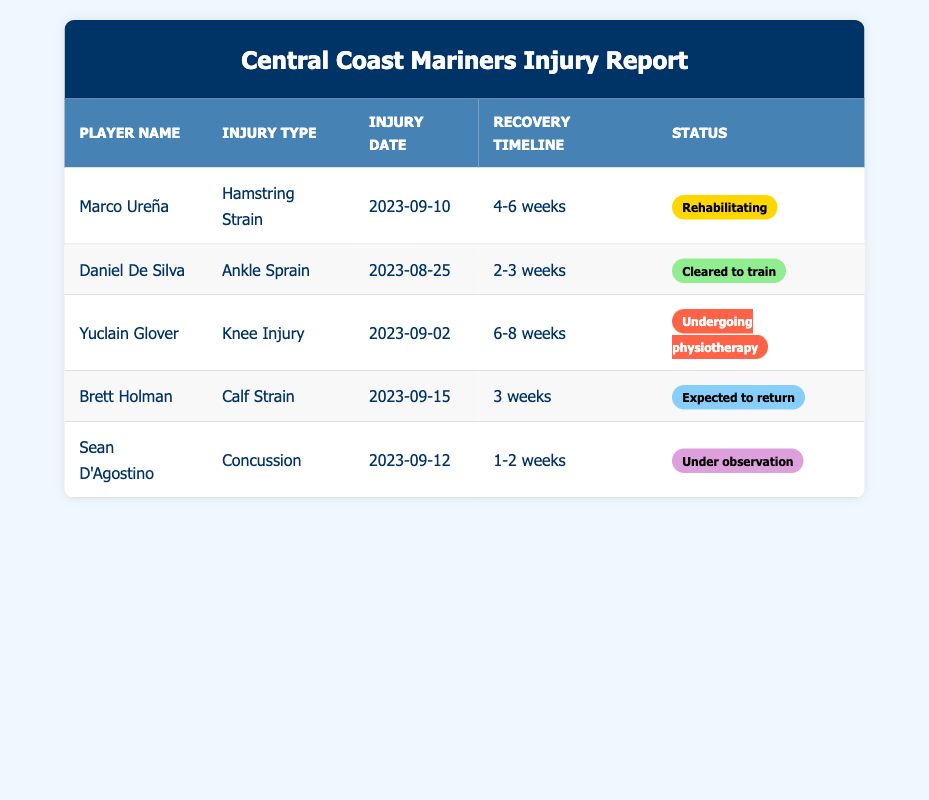What type of injury does Marco Ureña have? The table lists Marco Ureña's injury type as "Hamstring Strain." Since this information is shown directly in the "Injury Type" column for Marco Ureña, it's straightforward to retrieve.
Answer: Hamstring Strain When did Daniel De Silva sustain his injury? According to the table, Daniel De Silva's injury date is noted as "2023-08-25," which is found in the "Injury Date" column next to his name.
Answer: 2023-08-25 Which player has the longest expected recovery timeline? By comparing the recovery timelines in the table, Yuclain Glover has the longest estimated recovery period of "6-8 weeks." This is determined by looking at the "Recovery Timeline" column for each player and identifying the maximum duration.
Answer: Yuclain Glover Is Brett Holman expected to return to play soon? Yes, the table indicates that Brett Holman is marked as "Expected to return" with a recovery timeline of "3 weeks." This demonstrates that he is in the process of rehabilitating and will likely be back within a short duration.
Answer: Yes 